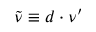Convert formula to latex. <formula><loc_0><loc_0><loc_500><loc_500>\widetilde { \nu } \equiv d \cdot \nu ^ { \prime }</formula> 